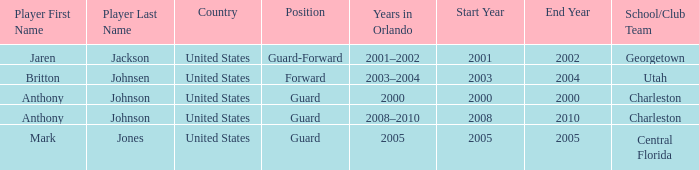What was the Position of the Player, Britton Johnsen? Forward. Give me the full table as a dictionary. {'header': ['Player First Name', 'Player Last Name', 'Country', 'Position', 'Years in Orlando', 'Start Year', 'End Year', 'School/Club Team'], 'rows': [['Jaren', 'Jackson', 'United States', 'Guard-Forward', '2001–2002', '2001', '2002', 'Georgetown'], ['Britton', 'Johnsen', 'United States', 'Forward', '2003–2004', '2003', '2004', 'Utah'], ['Anthony', 'Johnson', 'United States', 'Guard', '2000', '2000', '2000', 'Charleston'], ['Anthony', 'Johnson', 'United States', 'Guard', '2008–2010', '2008', '2010', 'Charleston'], ['Mark', 'Jones', 'United States', 'Guard', '2005', '2005', '2005', 'Central Florida']]} 